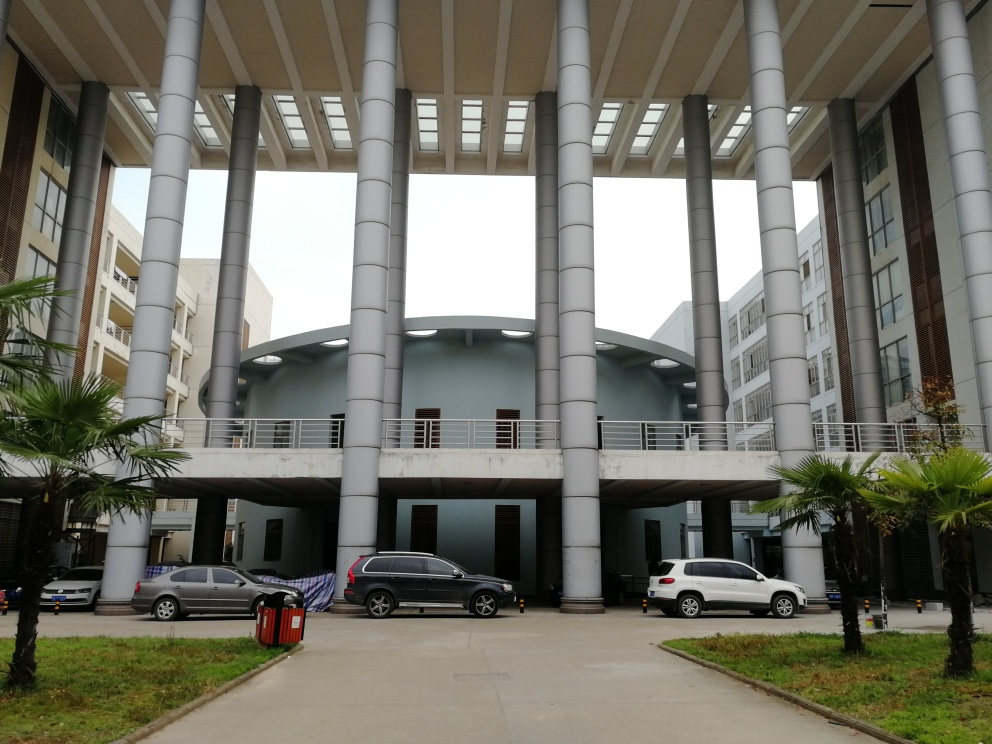What kind of weather or season does the sky suggest in this image? The sky appears overcast with a blanket of uniform clouds, suggesting it could be either an autumn or winter day. The absence of leaves on the tree to the right also supports the idea of it being a cooler season. However, the overall lighting condition suggests it's still daytime with diffused natural light. 